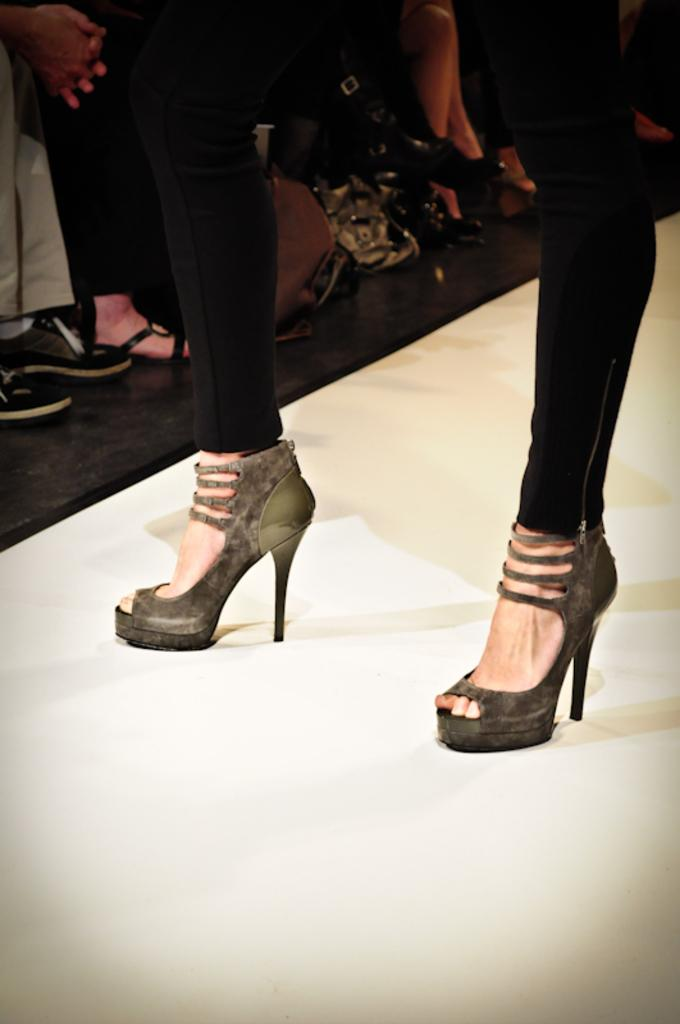Who is the main subject in the image? There is a woman in the image. What type of footwear is the woman wearing? The woman is wearing high heels. What part of the woman's body is visible in the image? The woman's legs are visible in the image. What is the color of the surface the woman is standing on? The woman is standing on a white surface. Can you describe the background of the image? There are other persons in the background of the image. What time is displayed on the clock in the image? There is no clock present in the image. How many things are visible on the white surface in the image? The question is unclear as it does not specify what "things" are being referred to. However, the woman and her high heels are visible on the white surface. 